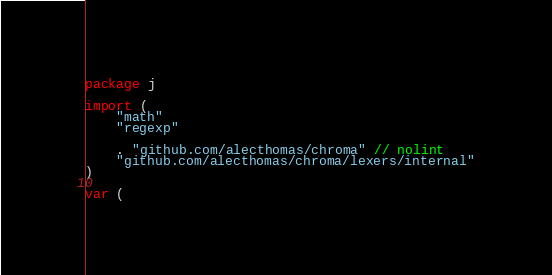Convert code to text. <code><loc_0><loc_0><loc_500><loc_500><_Go_>package j

import (
	"math"
	"regexp"

	. "github.com/alecthomas/chroma" // nolint
	"github.com/alecthomas/chroma/lexers/internal"
)

var (</code> 